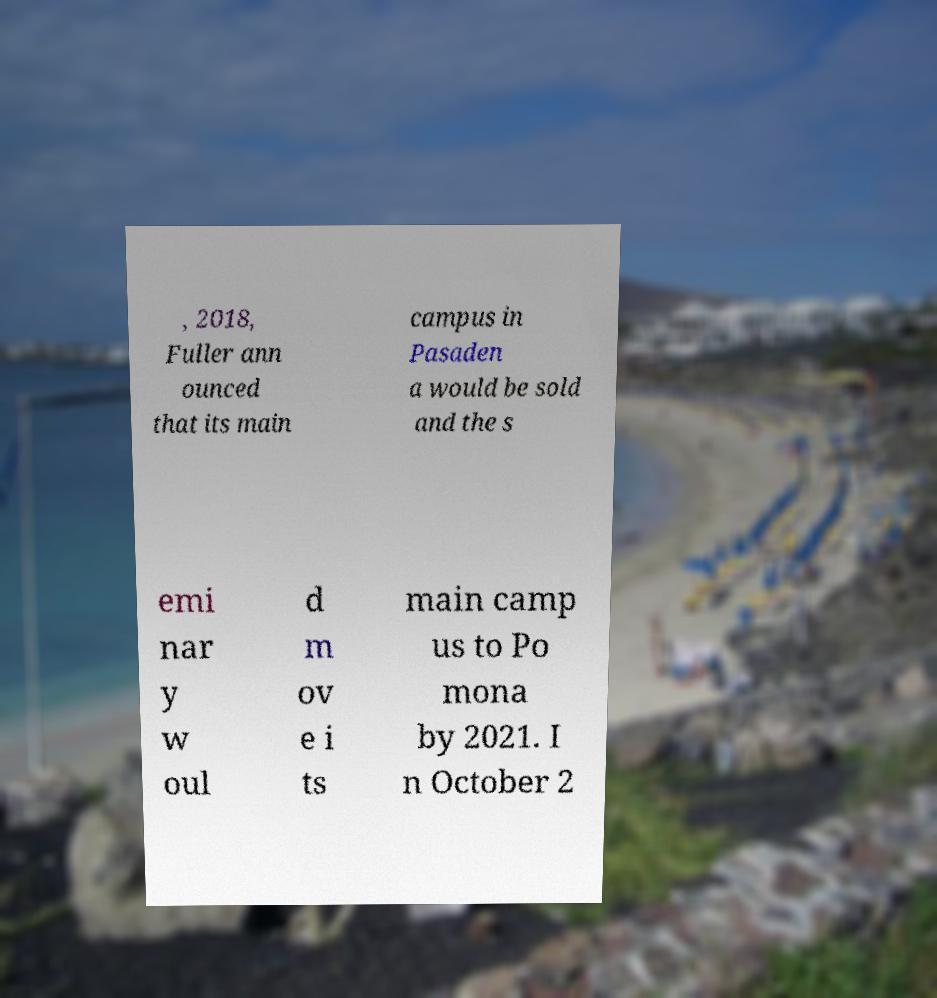For documentation purposes, I need the text within this image transcribed. Could you provide that? , 2018, Fuller ann ounced that its main campus in Pasaden a would be sold and the s emi nar y w oul d m ov e i ts main camp us to Po mona by 2021. I n October 2 